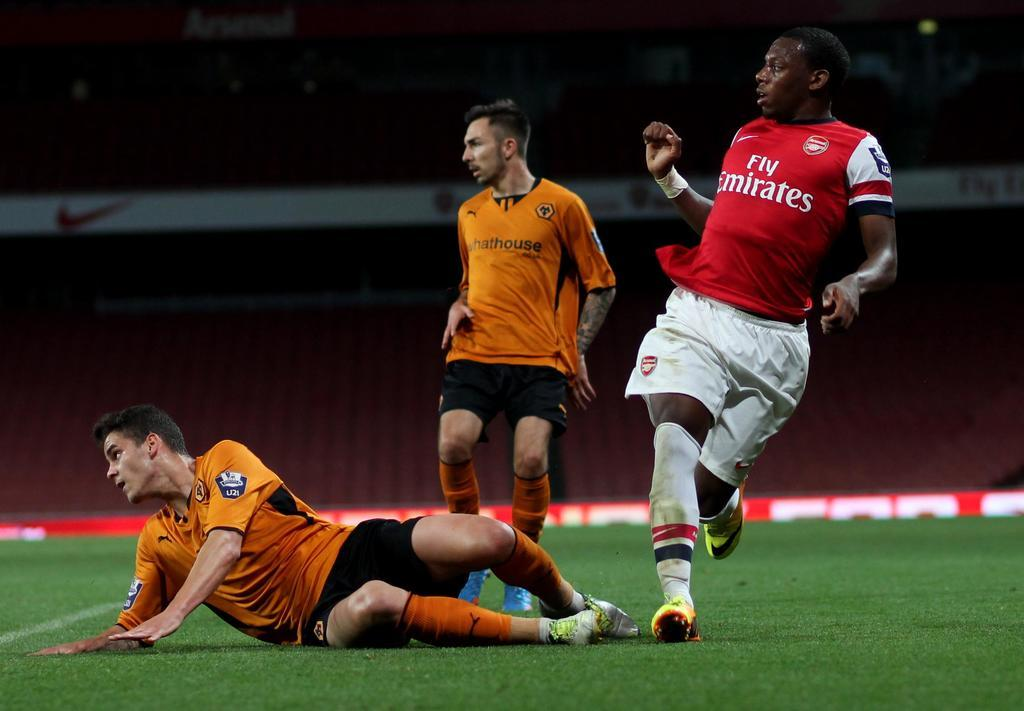Provide a one-sentence caption for the provided image. soccer players on a field with one jersey reading fly emirates. 